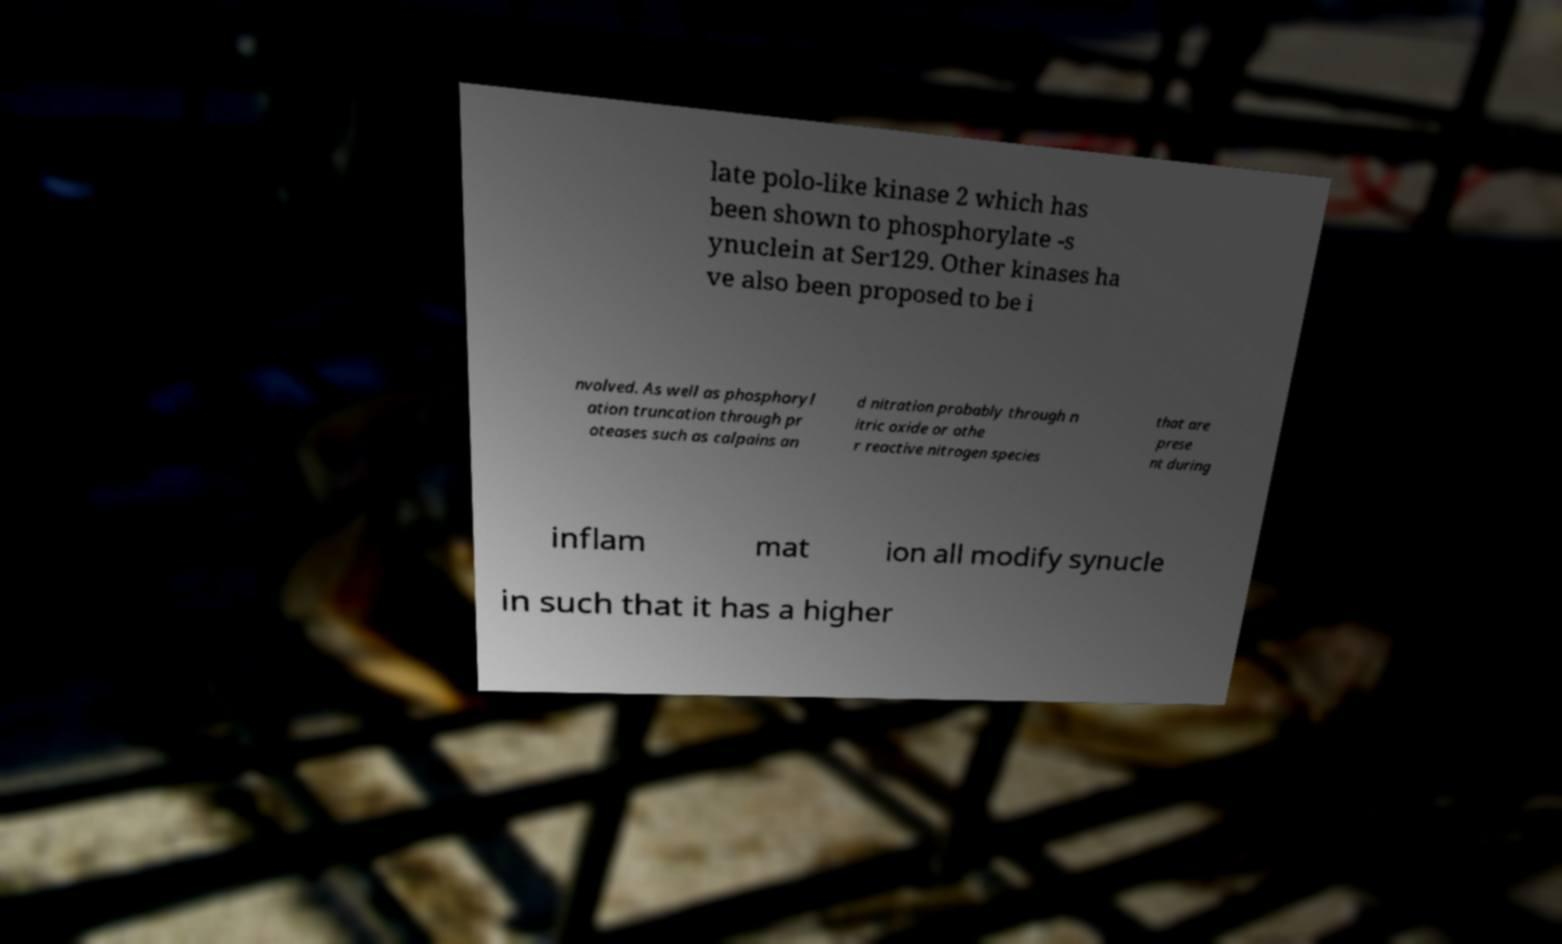Please read and relay the text visible in this image. What does it say? late polo-like kinase 2 which has been shown to phosphorylate -s ynuclein at Ser129. Other kinases ha ve also been proposed to be i nvolved. As well as phosphoryl ation truncation through pr oteases such as calpains an d nitration probably through n itric oxide or othe r reactive nitrogen species that are prese nt during inflam mat ion all modify synucle in such that it has a higher 